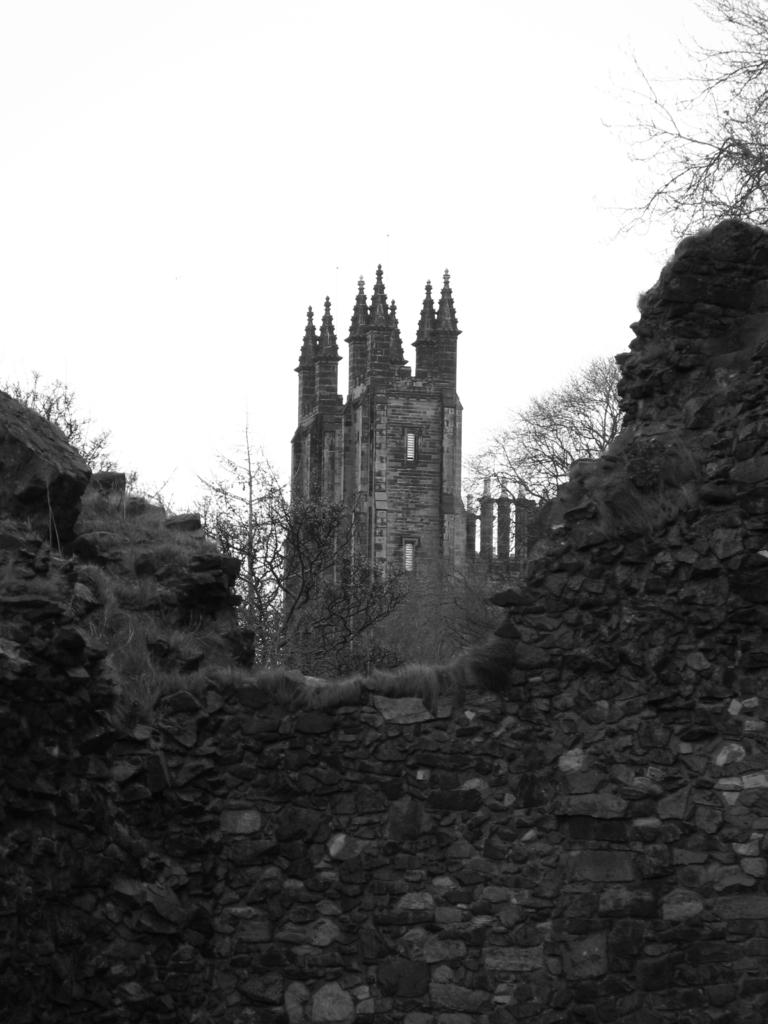What is the color scheme of the image? The image is black and white. What type of structure can be seen in the image? There is a fort in the image. What natural elements are present in the image? There are rocks and trees in the image. Where is the flock of birds located in the image? There are no birds or flock present in the image. What type of whip can be seen in the image? There is no whip present in the image. 